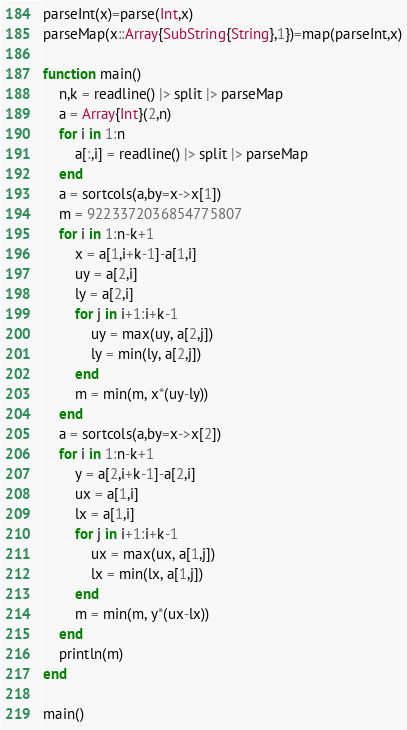<code> <loc_0><loc_0><loc_500><loc_500><_Julia_>parseInt(x)=parse(Int,x)
parseMap(x::Array{SubString{String},1})=map(parseInt,x)

function main()
	n,k = readline() |> split |> parseMap
	a = Array{Int}(2,n)
	for i in 1:n
		a[:,i] = readline() |> split |> parseMap
	end
	a = sortcols(a,by=x->x[1])
	m = 9223372036854775807
	for i in 1:n-k+1
		x = a[1,i+k-1]-a[1,i]
		uy = a[2,i]
		ly = a[2,i]
		for j in i+1:i+k-1
			uy = max(uy, a[2,j])
			ly = min(ly, a[2,j])
		end
		m = min(m, x*(uy-ly))
	end
	a = sortcols(a,by=x->x[2])
	for i in 1:n-k+1
		y = a[2,i+k-1]-a[2,i]
		ux = a[1,i]
		lx = a[1,i]
		for j in i+1:i+k-1
			ux = max(ux, a[1,j])
			lx = min(lx, a[1,j])
		end
		m = min(m, y*(ux-lx))
	end
	println(m)
end

main()</code> 